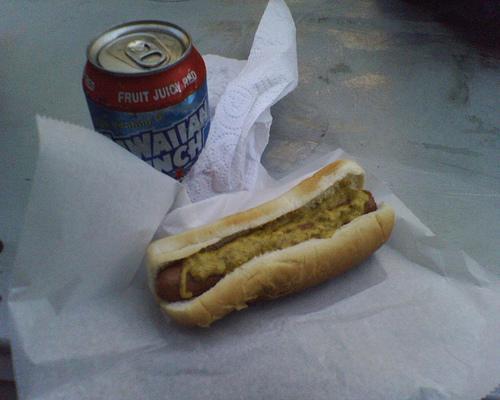How many giraffes are in the photo?
Give a very brief answer. 0. 